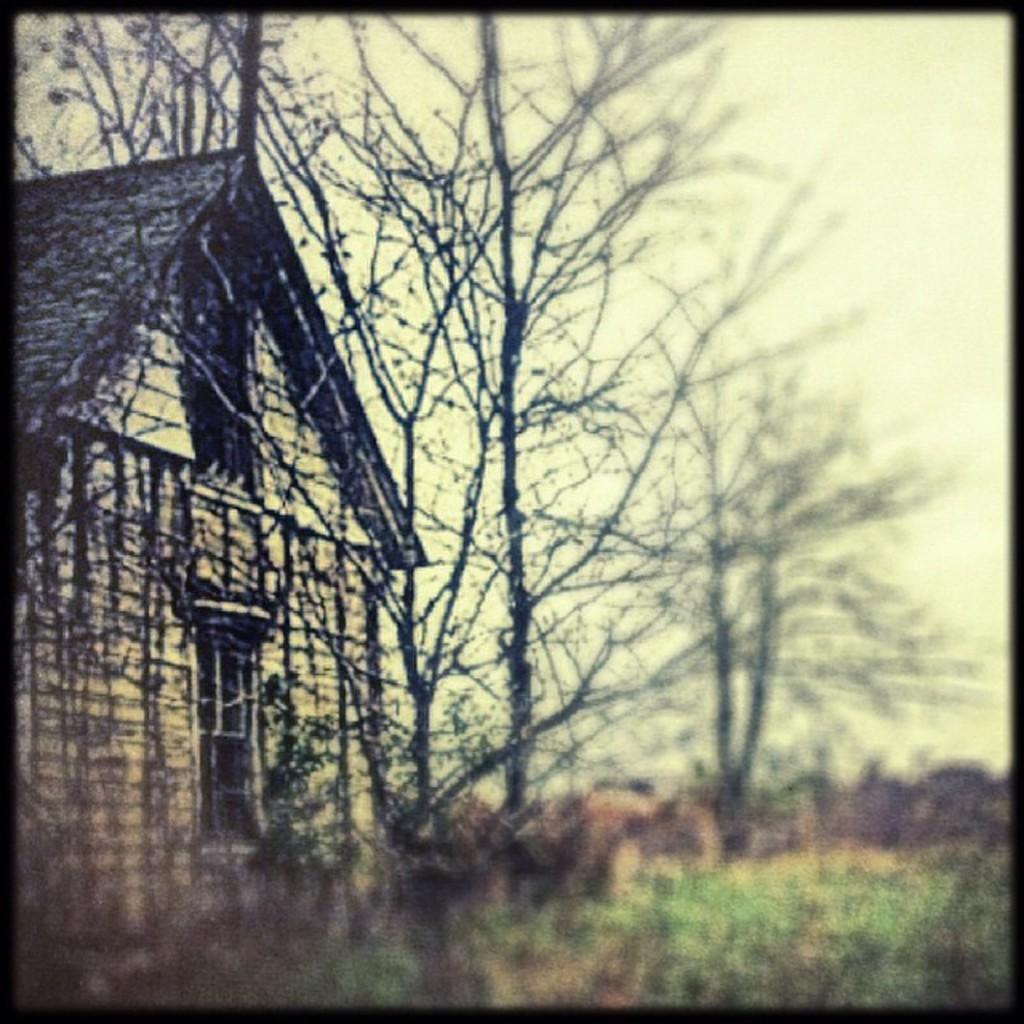Could you give a brief overview of what you see in this image? In this picture we can see a house and a few trees and stems. We can see a blur view at the bottom of the picture. 